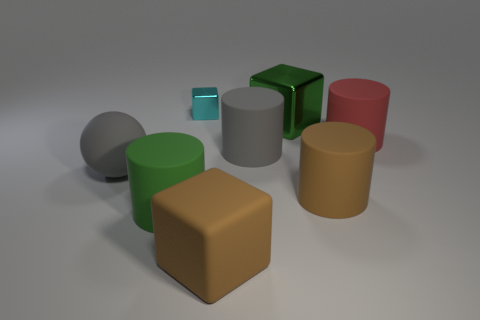Subtract all metallic cubes. How many cubes are left? 1 Add 2 metal blocks. How many objects exist? 10 Subtract all brown cylinders. How many cylinders are left? 3 Subtract all blocks. How many objects are left? 5 Subtract 3 blocks. How many blocks are left? 0 Subtract all tiny green rubber cylinders. Subtract all big brown cylinders. How many objects are left? 7 Add 7 large green cylinders. How many large green cylinders are left? 8 Add 1 big red matte objects. How many big red matte objects exist? 2 Subtract 1 gray spheres. How many objects are left? 7 Subtract all blue spheres. Subtract all yellow cylinders. How many spheres are left? 1 